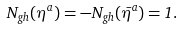<formula> <loc_0><loc_0><loc_500><loc_500>N _ { g h } ( \eta ^ { a } ) = - N _ { g h } ( \bar { \eta } ^ { a } ) = 1 .</formula> 